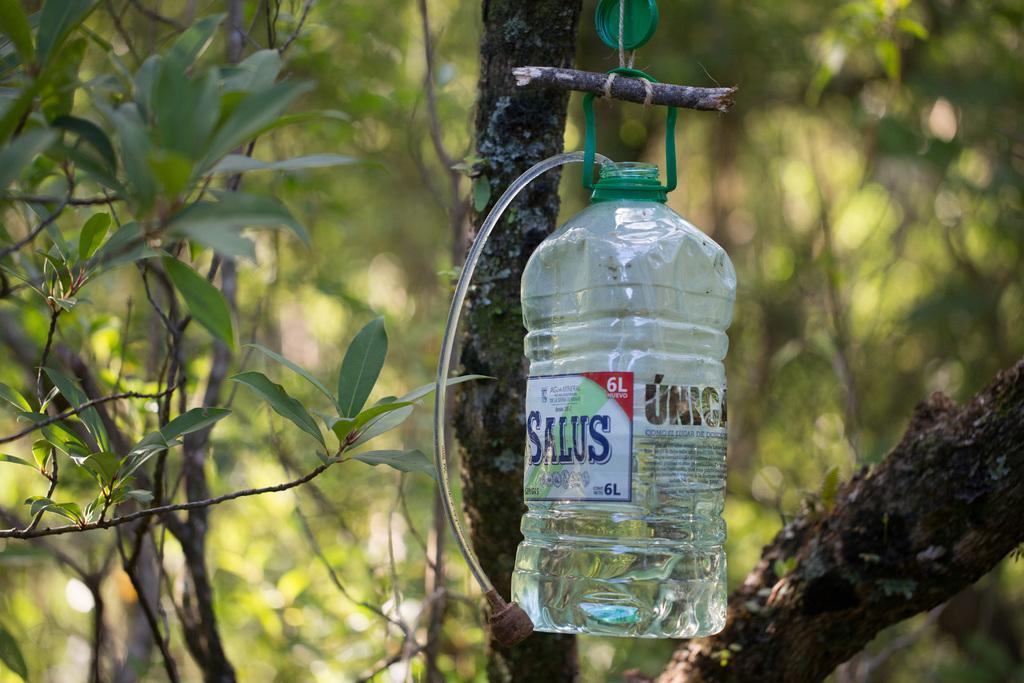Describe this image in one or two sentences. Here we can see a bottle hanged to the tree, and a label on it. 